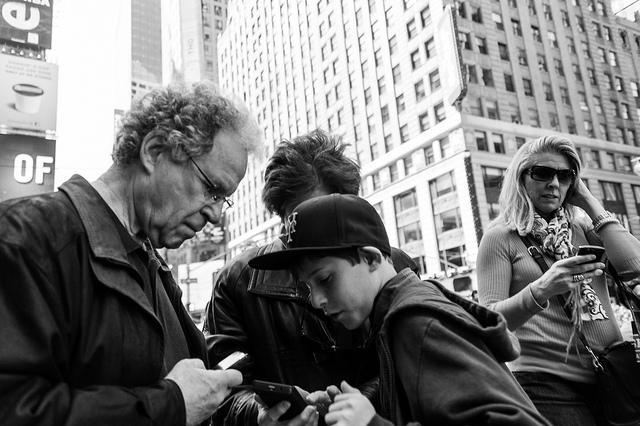What does the boy have on his head? baseball cap 